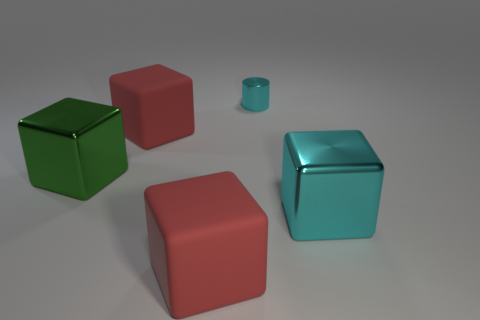What is the small cylinder made of? metal 